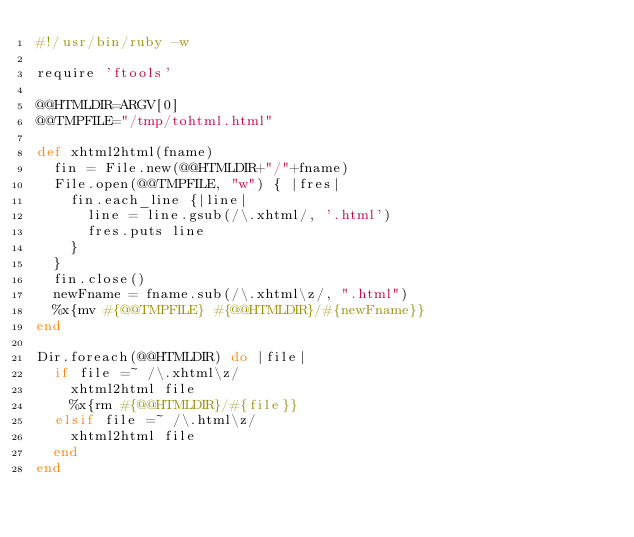Convert code to text. <code><loc_0><loc_0><loc_500><loc_500><_Ruby_>#!/usr/bin/ruby -w

require 'ftools'

@@HTMLDIR=ARGV[0]
@@TMPFILE="/tmp/tohtml.html"

def xhtml2html(fname)
  fin = File.new(@@HTMLDIR+"/"+fname)
  File.open(@@TMPFILE, "w") { |fres|
    fin.each_line {|line| 
      line = line.gsub(/\.xhtml/, '.html')
      fres.puts line
    }
  }
  fin.close()
  newFname = fname.sub(/\.xhtml\z/, ".html")
  %x{mv #{@@TMPFILE} #{@@HTMLDIR}/#{newFname}}
end

Dir.foreach(@@HTMLDIR) do |file|
  if file =~ /\.xhtml\z/ 
    xhtml2html file    
    %x{rm #{@@HTMLDIR}/#{file}}
  elsif file =~ /\.html\z/
    xhtml2html file    
  end
end


</code> 